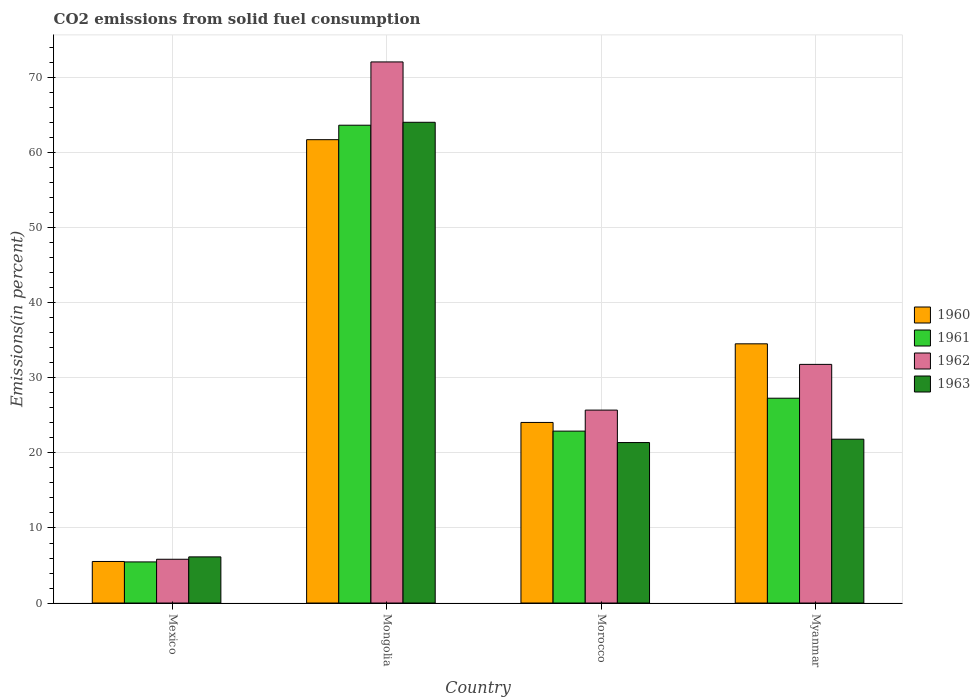Are the number of bars per tick equal to the number of legend labels?
Keep it short and to the point. Yes. Are the number of bars on each tick of the X-axis equal?
Provide a short and direct response. Yes. How many bars are there on the 2nd tick from the left?
Ensure brevity in your answer.  4. In how many cases, is the number of bars for a given country not equal to the number of legend labels?
Give a very brief answer. 0. What is the total CO2 emitted in 1962 in Myanmar?
Your answer should be compact. 31.81. Across all countries, what is the maximum total CO2 emitted in 1960?
Offer a terse response. 61.76. Across all countries, what is the minimum total CO2 emitted in 1961?
Your response must be concise. 5.48. In which country was the total CO2 emitted in 1961 maximum?
Keep it short and to the point. Mongolia. What is the total total CO2 emitted in 1960 in the graph?
Ensure brevity in your answer.  125.91. What is the difference between the total CO2 emitted in 1961 in Mexico and that in Mongolia?
Your answer should be very brief. -58.2. What is the difference between the total CO2 emitted in 1960 in Mexico and the total CO2 emitted in 1962 in Morocco?
Make the answer very short. -20.18. What is the average total CO2 emitted in 1962 per country?
Your response must be concise. 33.87. What is the difference between the total CO2 emitted of/in 1962 and total CO2 emitted of/in 1963 in Morocco?
Your response must be concise. 4.33. What is the ratio of the total CO2 emitted in 1960 in Morocco to that in Myanmar?
Give a very brief answer. 0.7. What is the difference between the highest and the second highest total CO2 emitted in 1961?
Provide a short and direct response. 4.39. What is the difference between the highest and the lowest total CO2 emitted in 1962?
Ensure brevity in your answer.  66.29. In how many countries, is the total CO2 emitted in 1962 greater than the average total CO2 emitted in 1962 taken over all countries?
Offer a terse response. 1. Is the sum of the total CO2 emitted in 1960 in Mexico and Morocco greater than the maximum total CO2 emitted in 1961 across all countries?
Keep it short and to the point. No. Is it the case that in every country, the sum of the total CO2 emitted in 1960 and total CO2 emitted in 1963 is greater than the sum of total CO2 emitted in 1962 and total CO2 emitted in 1961?
Your answer should be very brief. No. What does the 3rd bar from the right in Morocco represents?
Offer a very short reply. 1961. Is it the case that in every country, the sum of the total CO2 emitted in 1962 and total CO2 emitted in 1963 is greater than the total CO2 emitted in 1961?
Ensure brevity in your answer.  Yes. Are all the bars in the graph horizontal?
Offer a very short reply. No. How many countries are there in the graph?
Offer a very short reply. 4. Are the values on the major ticks of Y-axis written in scientific E-notation?
Give a very brief answer. No. Does the graph contain grids?
Offer a terse response. Yes. What is the title of the graph?
Your answer should be compact. CO2 emissions from solid fuel consumption. What is the label or title of the Y-axis?
Your answer should be very brief. Emissions(in percent). What is the Emissions(in percent) in 1960 in Mexico?
Offer a very short reply. 5.54. What is the Emissions(in percent) of 1961 in Mexico?
Ensure brevity in your answer.  5.48. What is the Emissions(in percent) of 1962 in Mexico?
Keep it short and to the point. 5.83. What is the Emissions(in percent) of 1963 in Mexico?
Make the answer very short. 6.15. What is the Emissions(in percent) of 1960 in Mongolia?
Give a very brief answer. 61.76. What is the Emissions(in percent) in 1961 in Mongolia?
Ensure brevity in your answer.  63.68. What is the Emissions(in percent) of 1962 in Mongolia?
Provide a short and direct response. 72.12. What is the Emissions(in percent) of 1963 in Mongolia?
Keep it short and to the point. 64.07. What is the Emissions(in percent) of 1960 in Morocco?
Your response must be concise. 24.07. What is the Emissions(in percent) of 1961 in Morocco?
Give a very brief answer. 22.91. What is the Emissions(in percent) of 1962 in Morocco?
Provide a short and direct response. 25.71. What is the Emissions(in percent) of 1963 in Morocco?
Provide a succinct answer. 21.39. What is the Emissions(in percent) in 1960 in Myanmar?
Offer a very short reply. 34.55. What is the Emissions(in percent) of 1961 in Myanmar?
Your answer should be very brief. 27.3. What is the Emissions(in percent) in 1962 in Myanmar?
Offer a very short reply. 31.81. What is the Emissions(in percent) of 1963 in Myanmar?
Offer a very short reply. 21.84. Across all countries, what is the maximum Emissions(in percent) of 1960?
Your response must be concise. 61.76. Across all countries, what is the maximum Emissions(in percent) of 1961?
Your answer should be very brief. 63.68. Across all countries, what is the maximum Emissions(in percent) in 1962?
Ensure brevity in your answer.  72.12. Across all countries, what is the maximum Emissions(in percent) of 1963?
Ensure brevity in your answer.  64.07. Across all countries, what is the minimum Emissions(in percent) of 1960?
Offer a very short reply. 5.54. Across all countries, what is the minimum Emissions(in percent) of 1961?
Provide a succinct answer. 5.48. Across all countries, what is the minimum Emissions(in percent) of 1962?
Make the answer very short. 5.83. Across all countries, what is the minimum Emissions(in percent) of 1963?
Provide a short and direct response. 6.15. What is the total Emissions(in percent) in 1960 in the graph?
Provide a short and direct response. 125.91. What is the total Emissions(in percent) of 1961 in the graph?
Your answer should be compact. 119.38. What is the total Emissions(in percent) in 1962 in the graph?
Your answer should be very brief. 135.47. What is the total Emissions(in percent) of 1963 in the graph?
Your answer should be very brief. 113.45. What is the difference between the Emissions(in percent) of 1960 in Mexico and that in Mongolia?
Offer a terse response. -56.22. What is the difference between the Emissions(in percent) of 1961 in Mexico and that in Mongolia?
Your answer should be very brief. -58.2. What is the difference between the Emissions(in percent) in 1962 in Mexico and that in Mongolia?
Give a very brief answer. -66.29. What is the difference between the Emissions(in percent) of 1963 in Mexico and that in Mongolia?
Your answer should be very brief. -57.92. What is the difference between the Emissions(in percent) of 1960 in Mexico and that in Morocco?
Offer a very short reply. -18.53. What is the difference between the Emissions(in percent) of 1961 in Mexico and that in Morocco?
Keep it short and to the point. -17.43. What is the difference between the Emissions(in percent) in 1962 in Mexico and that in Morocco?
Keep it short and to the point. -19.88. What is the difference between the Emissions(in percent) of 1963 in Mexico and that in Morocco?
Your response must be concise. -15.24. What is the difference between the Emissions(in percent) in 1960 in Mexico and that in Myanmar?
Your answer should be very brief. -29.01. What is the difference between the Emissions(in percent) of 1961 in Mexico and that in Myanmar?
Make the answer very short. -21.82. What is the difference between the Emissions(in percent) of 1962 in Mexico and that in Myanmar?
Make the answer very short. -25.97. What is the difference between the Emissions(in percent) of 1963 in Mexico and that in Myanmar?
Keep it short and to the point. -15.69. What is the difference between the Emissions(in percent) in 1960 in Mongolia and that in Morocco?
Offer a terse response. 37.69. What is the difference between the Emissions(in percent) in 1961 in Mongolia and that in Morocco?
Make the answer very short. 40.77. What is the difference between the Emissions(in percent) of 1962 in Mongolia and that in Morocco?
Make the answer very short. 46.4. What is the difference between the Emissions(in percent) in 1963 in Mongolia and that in Morocco?
Give a very brief answer. 42.68. What is the difference between the Emissions(in percent) in 1960 in Mongolia and that in Myanmar?
Make the answer very short. 27.21. What is the difference between the Emissions(in percent) of 1961 in Mongolia and that in Myanmar?
Provide a succinct answer. 36.39. What is the difference between the Emissions(in percent) of 1962 in Mongolia and that in Myanmar?
Offer a very short reply. 40.31. What is the difference between the Emissions(in percent) in 1963 in Mongolia and that in Myanmar?
Keep it short and to the point. 42.24. What is the difference between the Emissions(in percent) in 1960 in Morocco and that in Myanmar?
Offer a terse response. -10.48. What is the difference between the Emissions(in percent) in 1961 in Morocco and that in Myanmar?
Your response must be concise. -4.39. What is the difference between the Emissions(in percent) in 1962 in Morocco and that in Myanmar?
Make the answer very short. -6.09. What is the difference between the Emissions(in percent) of 1963 in Morocco and that in Myanmar?
Keep it short and to the point. -0.45. What is the difference between the Emissions(in percent) of 1960 in Mexico and the Emissions(in percent) of 1961 in Mongolia?
Ensure brevity in your answer.  -58.15. What is the difference between the Emissions(in percent) in 1960 in Mexico and the Emissions(in percent) in 1962 in Mongolia?
Your answer should be compact. -66.58. What is the difference between the Emissions(in percent) in 1960 in Mexico and the Emissions(in percent) in 1963 in Mongolia?
Your answer should be very brief. -58.54. What is the difference between the Emissions(in percent) in 1961 in Mexico and the Emissions(in percent) in 1962 in Mongolia?
Make the answer very short. -66.64. What is the difference between the Emissions(in percent) of 1961 in Mexico and the Emissions(in percent) of 1963 in Mongolia?
Provide a short and direct response. -58.59. What is the difference between the Emissions(in percent) of 1962 in Mexico and the Emissions(in percent) of 1963 in Mongolia?
Offer a very short reply. -58.24. What is the difference between the Emissions(in percent) of 1960 in Mexico and the Emissions(in percent) of 1961 in Morocco?
Provide a succinct answer. -17.38. What is the difference between the Emissions(in percent) in 1960 in Mexico and the Emissions(in percent) in 1962 in Morocco?
Offer a terse response. -20.18. What is the difference between the Emissions(in percent) in 1960 in Mexico and the Emissions(in percent) in 1963 in Morocco?
Your answer should be compact. -15.85. What is the difference between the Emissions(in percent) of 1961 in Mexico and the Emissions(in percent) of 1962 in Morocco?
Keep it short and to the point. -20.23. What is the difference between the Emissions(in percent) in 1961 in Mexico and the Emissions(in percent) in 1963 in Morocco?
Your answer should be very brief. -15.91. What is the difference between the Emissions(in percent) in 1962 in Mexico and the Emissions(in percent) in 1963 in Morocco?
Provide a succinct answer. -15.56. What is the difference between the Emissions(in percent) of 1960 in Mexico and the Emissions(in percent) of 1961 in Myanmar?
Give a very brief answer. -21.76. What is the difference between the Emissions(in percent) of 1960 in Mexico and the Emissions(in percent) of 1962 in Myanmar?
Make the answer very short. -26.27. What is the difference between the Emissions(in percent) in 1960 in Mexico and the Emissions(in percent) in 1963 in Myanmar?
Your answer should be very brief. -16.3. What is the difference between the Emissions(in percent) of 1961 in Mexico and the Emissions(in percent) of 1962 in Myanmar?
Provide a short and direct response. -26.33. What is the difference between the Emissions(in percent) in 1961 in Mexico and the Emissions(in percent) in 1963 in Myanmar?
Offer a terse response. -16.36. What is the difference between the Emissions(in percent) in 1962 in Mexico and the Emissions(in percent) in 1963 in Myanmar?
Keep it short and to the point. -16. What is the difference between the Emissions(in percent) in 1960 in Mongolia and the Emissions(in percent) in 1961 in Morocco?
Ensure brevity in your answer.  38.84. What is the difference between the Emissions(in percent) in 1960 in Mongolia and the Emissions(in percent) in 1962 in Morocco?
Give a very brief answer. 36.04. What is the difference between the Emissions(in percent) in 1960 in Mongolia and the Emissions(in percent) in 1963 in Morocco?
Provide a short and direct response. 40.37. What is the difference between the Emissions(in percent) in 1961 in Mongolia and the Emissions(in percent) in 1962 in Morocco?
Your answer should be very brief. 37.97. What is the difference between the Emissions(in percent) in 1961 in Mongolia and the Emissions(in percent) in 1963 in Morocco?
Keep it short and to the point. 42.3. What is the difference between the Emissions(in percent) of 1962 in Mongolia and the Emissions(in percent) of 1963 in Morocco?
Your answer should be very brief. 50.73. What is the difference between the Emissions(in percent) of 1960 in Mongolia and the Emissions(in percent) of 1961 in Myanmar?
Offer a very short reply. 34.46. What is the difference between the Emissions(in percent) in 1960 in Mongolia and the Emissions(in percent) in 1962 in Myanmar?
Make the answer very short. 29.95. What is the difference between the Emissions(in percent) of 1960 in Mongolia and the Emissions(in percent) of 1963 in Myanmar?
Ensure brevity in your answer.  39.92. What is the difference between the Emissions(in percent) in 1961 in Mongolia and the Emissions(in percent) in 1962 in Myanmar?
Provide a succinct answer. 31.88. What is the difference between the Emissions(in percent) of 1961 in Mongolia and the Emissions(in percent) of 1963 in Myanmar?
Provide a succinct answer. 41.85. What is the difference between the Emissions(in percent) of 1962 in Mongolia and the Emissions(in percent) of 1963 in Myanmar?
Provide a succinct answer. 50.28. What is the difference between the Emissions(in percent) of 1960 in Morocco and the Emissions(in percent) of 1961 in Myanmar?
Your response must be concise. -3.23. What is the difference between the Emissions(in percent) of 1960 in Morocco and the Emissions(in percent) of 1962 in Myanmar?
Your response must be concise. -7.74. What is the difference between the Emissions(in percent) of 1960 in Morocco and the Emissions(in percent) of 1963 in Myanmar?
Provide a succinct answer. 2.23. What is the difference between the Emissions(in percent) in 1961 in Morocco and the Emissions(in percent) in 1962 in Myanmar?
Offer a terse response. -8.89. What is the difference between the Emissions(in percent) of 1961 in Morocco and the Emissions(in percent) of 1963 in Myanmar?
Keep it short and to the point. 1.08. What is the difference between the Emissions(in percent) of 1962 in Morocco and the Emissions(in percent) of 1963 in Myanmar?
Provide a succinct answer. 3.88. What is the average Emissions(in percent) of 1960 per country?
Keep it short and to the point. 31.48. What is the average Emissions(in percent) of 1961 per country?
Give a very brief answer. 29.84. What is the average Emissions(in percent) in 1962 per country?
Provide a succinct answer. 33.87. What is the average Emissions(in percent) in 1963 per country?
Ensure brevity in your answer.  28.36. What is the difference between the Emissions(in percent) of 1960 and Emissions(in percent) of 1961 in Mexico?
Make the answer very short. 0.06. What is the difference between the Emissions(in percent) in 1960 and Emissions(in percent) in 1962 in Mexico?
Make the answer very short. -0.3. What is the difference between the Emissions(in percent) of 1960 and Emissions(in percent) of 1963 in Mexico?
Ensure brevity in your answer.  -0.61. What is the difference between the Emissions(in percent) in 1961 and Emissions(in percent) in 1962 in Mexico?
Your answer should be compact. -0.35. What is the difference between the Emissions(in percent) in 1961 and Emissions(in percent) in 1963 in Mexico?
Make the answer very short. -0.67. What is the difference between the Emissions(in percent) in 1962 and Emissions(in percent) in 1963 in Mexico?
Give a very brief answer. -0.32. What is the difference between the Emissions(in percent) of 1960 and Emissions(in percent) of 1961 in Mongolia?
Your response must be concise. -1.93. What is the difference between the Emissions(in percent) of 1960 and Emissions(in percent) of 1962 in Mongolia?
Give a very brief answer. -10.36. What is the difference between the Emissions(in percent) in 1960 and Emissions(in percent) in 1963 in Mongolia?
Make the answer very short. -2.32. What is the difference between the Emissions(in percent) in 1961 and Emissions(in percent) in 1962 in Mongolia?
Provide a short and direct response. -8.43. What is the difference between the Emissions(in percent) in 1961 and Emissions(in percent) in 1963 in Mongolia?
Your answer should be compact. -0.39. What is the difference between the Emissions(in percent) of 1962 and Emissions(in percent) of 1963 in Mongolia?
Offer a terse response. 8.05. What is the difference between the Emissions(in percent) in 1960 and Emissions(in percent) in 1961 in Morocco?
Your answer should be compact. 1.16. What is the difference between the Emissions(in percent) in 1960 and Emissions(in percent) in 1962 in Morocco?
Ensure brevity in your answer.  -1.65. What is the difference between the Emissions(in percent) of 1960 and Emissions(in percent) of 1963 in Morocco?
Make the answer very short. 2.68. What is the difference between the Emissions(in percent) of 1961 and Emissions(in percent) of 1962 in Morocco?
Make the answer very short. -2.8. What is the difference between the Emissions(in percent) in 1961 and Emissions(in percent) in 1963 in Morocco?
Your response must be concise. 1.52. What is the difference between the Emissions(in percent) in 1962 and Emissions(in percent) in 1963 in Morocco?
Keep it short and to the point. 4.33. What is the difference between the Emissions(in percent) in 1960 and Emissions(in percent) in 1961 in Myanmar?
Offer a terse response. 7.25. What is the difference between the Emissions(in percent) of 1960 and Emissions(in percent) of 1962 in Myanmar?
Give a very brief answer. 2.74. What is the difference between the Emissions(in percent) of 1960 and Emissions(in percent) of 1963 in Myanmar?
Offer a very short reply. 12.71. What is the difference between the Emissions(in percent) of 1961 and Emissions(in percent) of 1962 in Myanmar?
Provide a succinct answer. -4.51. What is the difference between the Emissions(in percent) of 1961 and Emissions(in percent) of 1963 in Myanmar?
Provide a succinct answer. 5.46. What is the difference between the Emissions(in percent) in 1962 and Emissions(in percent) in 1963 in Myanmar?
Ensure brevity in your answer.  9.97. What is the ratio of the Emissions(in percent) of 1960 in Mexico to that in Mongolia?
Give a very brief answer. 0.09. What is the ratio of the Emissions(in percent) in 1961 in Mexico to that in Mongolia?
Your response must be concise. 0.09. What is the ratio of the Emissions(in percent) in 1962 in Mexico to that in Mongolia?
Ensure brevity in your answer.  0.08. What is the ratio of the Emissions(in percent) in 1963 in Mexico to that in Mongolia?
Your answer should be very brief. 0.1. What is the ratio of the Emissions(in percent) in 1960 in Mexico to that in Morocco?
Keep it short and to the point. 0.23. What is the ratio of the Emissions(in percent) in 1961 in Mexico to that in Morocco?
Your response must be concise. 0.24. What is the ratio of the Emissions(in percent) in 1962 in Mexico to that in Morocco?
Make the answer very short. 0.23. What is the ratio of the Emissions(in percent) in 1963 in Mexico to that in Morocco?
Ensure brevity in your answer.  0.29. What is the ratio of the Emissions(in percent) in 1960 in Mexico to that in Myanmar?
Provide a short and direct response. 0.16. What is the ratio of the Emissions(in percent) of 1961 in Mexico to that in Myanmar?
Your answer should be very brief. 0.2. What is the ratio of the Emissions(in percent) in 1962 in Mexico to that in Myanmar?
Your response must be concise. 0.18. What is the ratio of the Emissions(in percent) of 1963 in Mexico to that in Myanmar?
Give a very brief answer. 0.28. What is the ratio of the Emissions(in percent) in 1960 in Mongolia to that in Morocco?
Provide a succinct answer. 2.57. What is the ratio of the Emissions(in percent) of 1961 in Mongolia to that in Morocco?
Offer a terse response. 2.78. What is the ratio of the Emissions(in percent) of 1962 in Mongolia to that in Morocco?
Provide a short and direct response. 2.8. What is the ratio of the Emissions(in percent) in 1963 in Mongolia to that in Morocco?
Give a very brief answer. 3. What is the ratio of the Emissions(in percent) of 1960 in Mongolia to that in Myanmar?
Provide a short and direct response. 1.79. What is the ratio of the Emissions(in percent) in 1961 in Mongolia to that in Myanmar?
Your answer should be very brief. 2.33. What is the ratio of the Emissions(in percent) in 1962 in Mongolia to that in Myanmar?
Provide a short and direct response. 2.27. What is the ratio of the Emissions(in percent) in 1963 in Mongolia to that in Myanmar?
Your answer should be compact. 2.93. What is the ratio of the Emissions(in percent) of 1960 in Morocco to that in Myanmar?
Your response must be concise. 0.7. What is the ratio of the Emissions(in percent) of 1961 in Morocco to that in Myanmar?
Your response must be concise. 0.84. What is the ratio of the Emissions(in percent) of 1962 in Morocco to that in Myanmar?
Give a very brief answer. 0.81. What is the ratio of the Emissions(in percent) of 1963 in Morocco to that in Myanmar?
Give a very brief answer. 0.98. What is the difference between the highest and the second highest Emissions(in percent) in 1960?
Give a very brief answer. 27.21. What is the difference between the highest and the second highest Emissions(in percent) in 1961?
Make the answer very short. 36.39. What is the difference between the highest and the second highest Emissions(in percent) of 1962?
Ensure brevity in your answer.  40.31. What is the difference between the highest and the second highest Emissions(in percent) of 1963?
Provide a succinct answer. 42.24. What is the difference between the highest and the lowest Emissions(in percent) of 1960?
Provide a short and direct response. 56.22. What is the difference between the highest and the lowest Emissions(in percent) of 1961?
Give a very brief answer. 58.2. What is the difference between the highest and the lowest Emissions(in percent) of 1962?
Offer a terse response. 66.29. What is the difference between the highest and the lowest Emissions(in percent) of 1963?
Offer a very short reply. 57.92. 